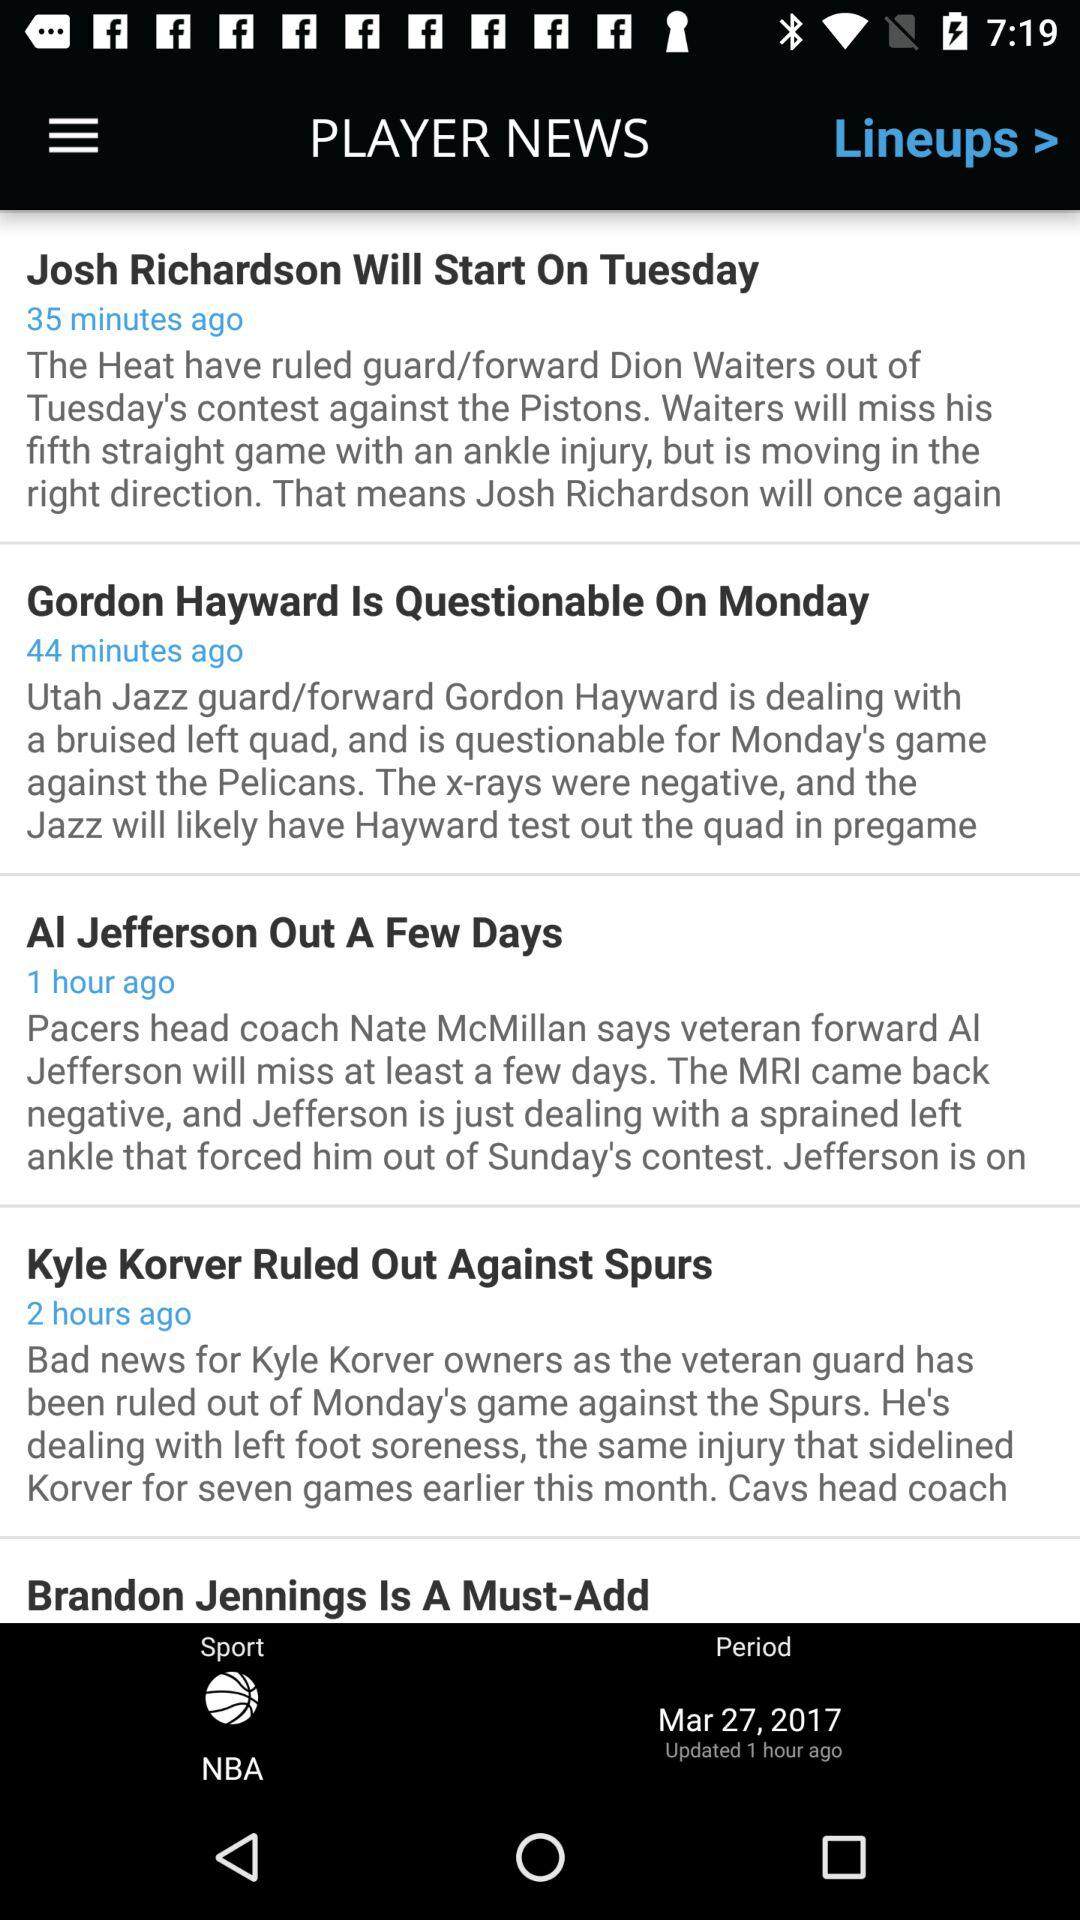How long ago was the news "Brandon Jennings Is A Must-Add" posted?
When the provided information is insufficient, respond with <no answer>. <no answer> 